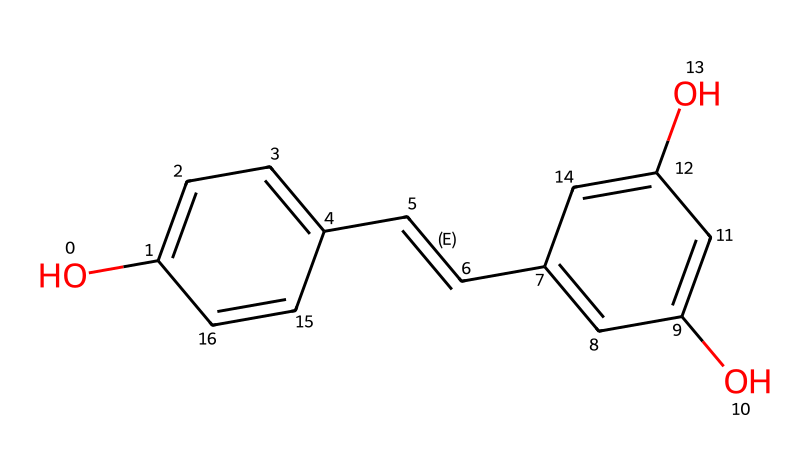What is the primary functional group in resveratrol? The structure features hydroxyl groups (-OH) attached to benzene rings, which indicates the presence of phenolic functional groups.
Answer: hydroxyl How many carbon atoms are present in the resveratrol structure? Counting the carbon atoms in the SMILES representation, there are 14 carbon atoms present in the structure of resveratrol.
Answer: fourteen What type of chemical compound is resveratrol classified as? Resveratrol has multiple hydroxyl groups and a basic carbon structure that are characteristic of phenolic compounds.
Answer: phenol How many double bonds are present in the resveratrol molecule? By examining the structure, there are two double bonds indicated in the carbon-carbon connections, specifically noticeable in the alkene portion.
Answer: two What health benefit is resveratrol commonly associated with? Resveratrol is often linked to cardiovascular health improvements and antioxidant properties, providing a basis for its study in relation to heart disease and aging.
Answer: cardiovascular Which two groups are featured in resveratrol's structure? The presence of the two hydroxyl (-OH) groups and the carbon-carbon double bond (-C=C-) are the significant features of resveratrol's molecular structure.
Answer: hydroxyl and double bond 